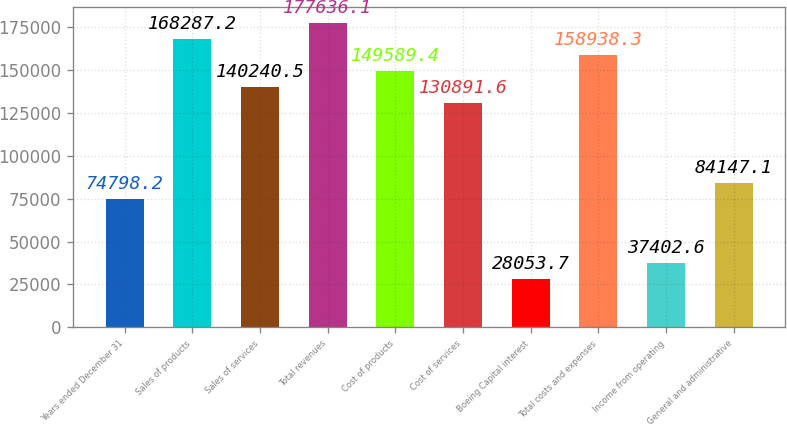Convert chart to OTSL. <chart><loc_0><loc_0><loc_500><loc_500><bar_chart><fcel>Years ended December 31<fcel>Sales of products<fcel>Sales of services<fcel>Total revenues<fcel>Cost of products<fcel>Cost of services<fcel>Boeing Capital interest<fcel>Total costs and expenses<fcel>Income from operating<fcel>General and administrative<nl><fcel>74798.2<fcel>168287<fcel>140240<fcel>177636<fcel>149589<fcel>130892<fcel>28053.7<fcel>158938<fcel>37402.6<fcel>84147.1<nl></chart> 